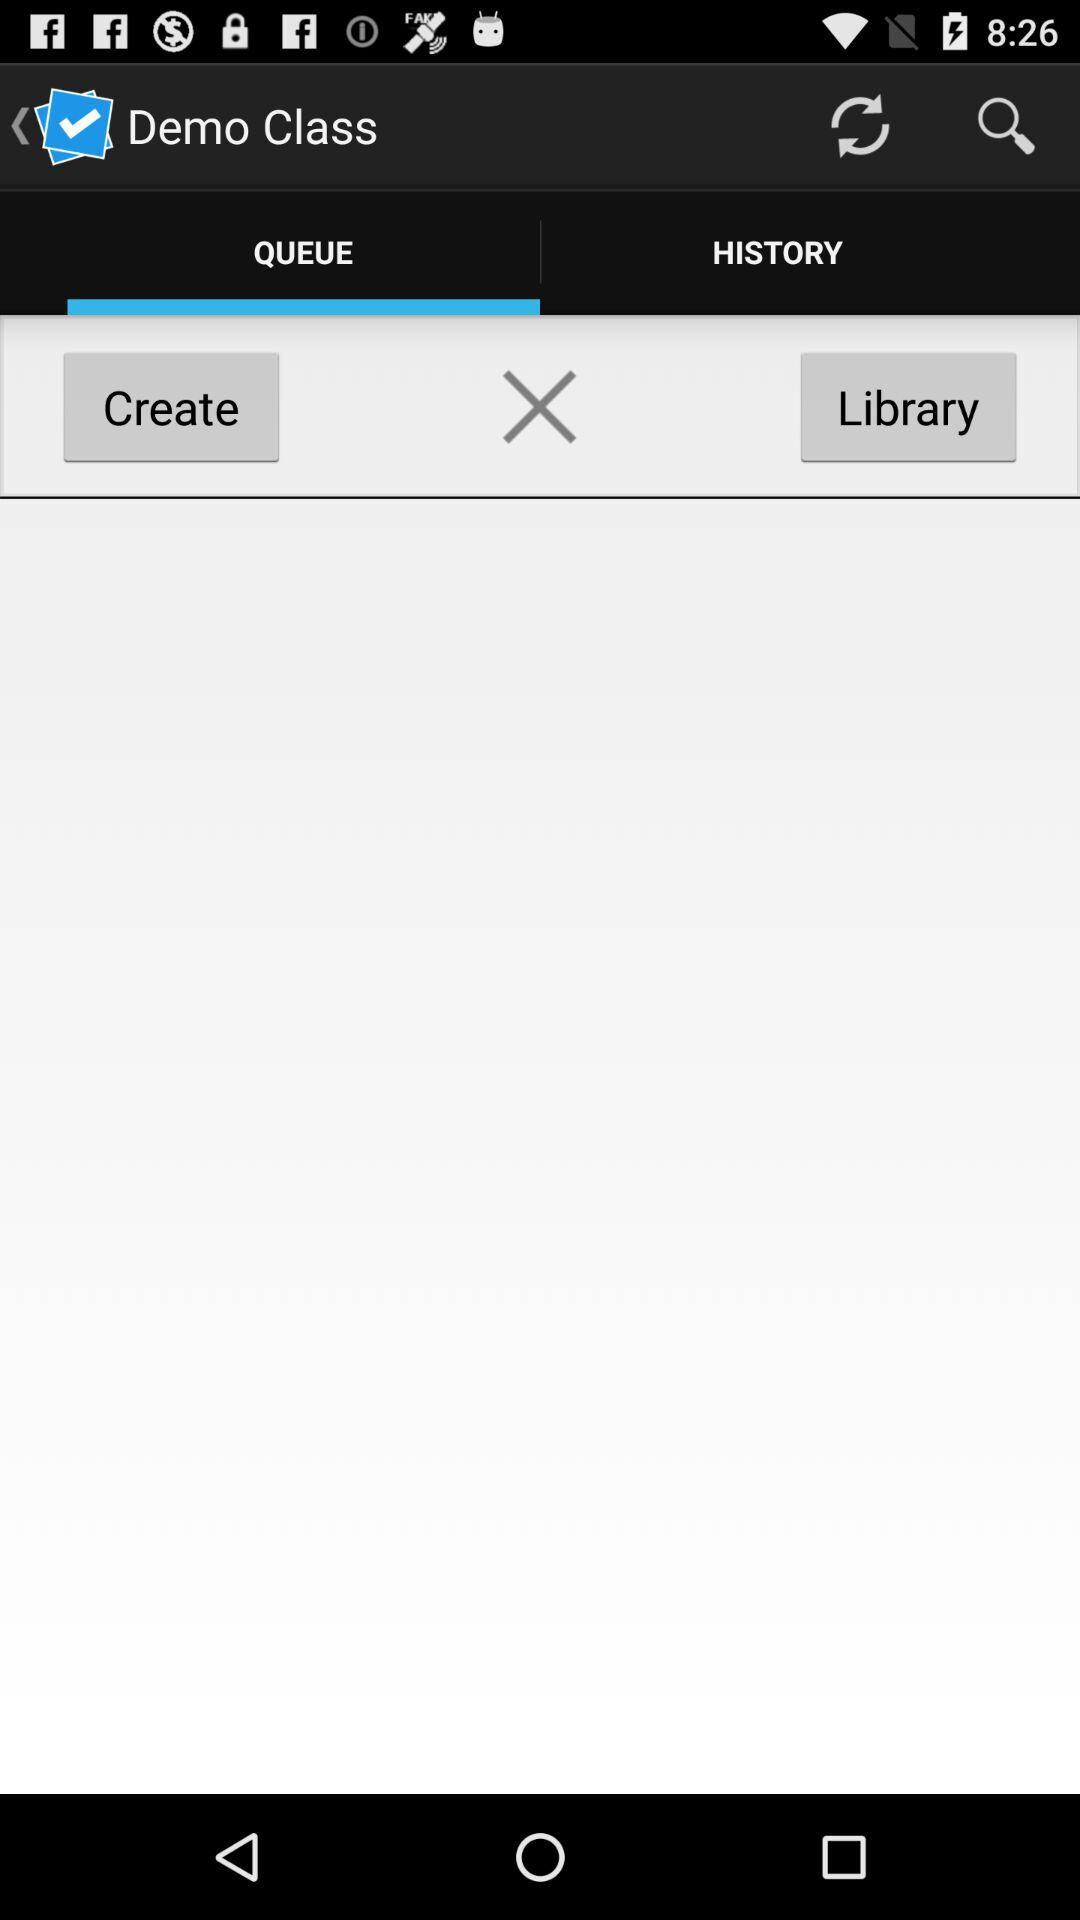How many items are in "HISTORY"?
When the provided information is insufficient, respond with <no answer>. <no answer> 